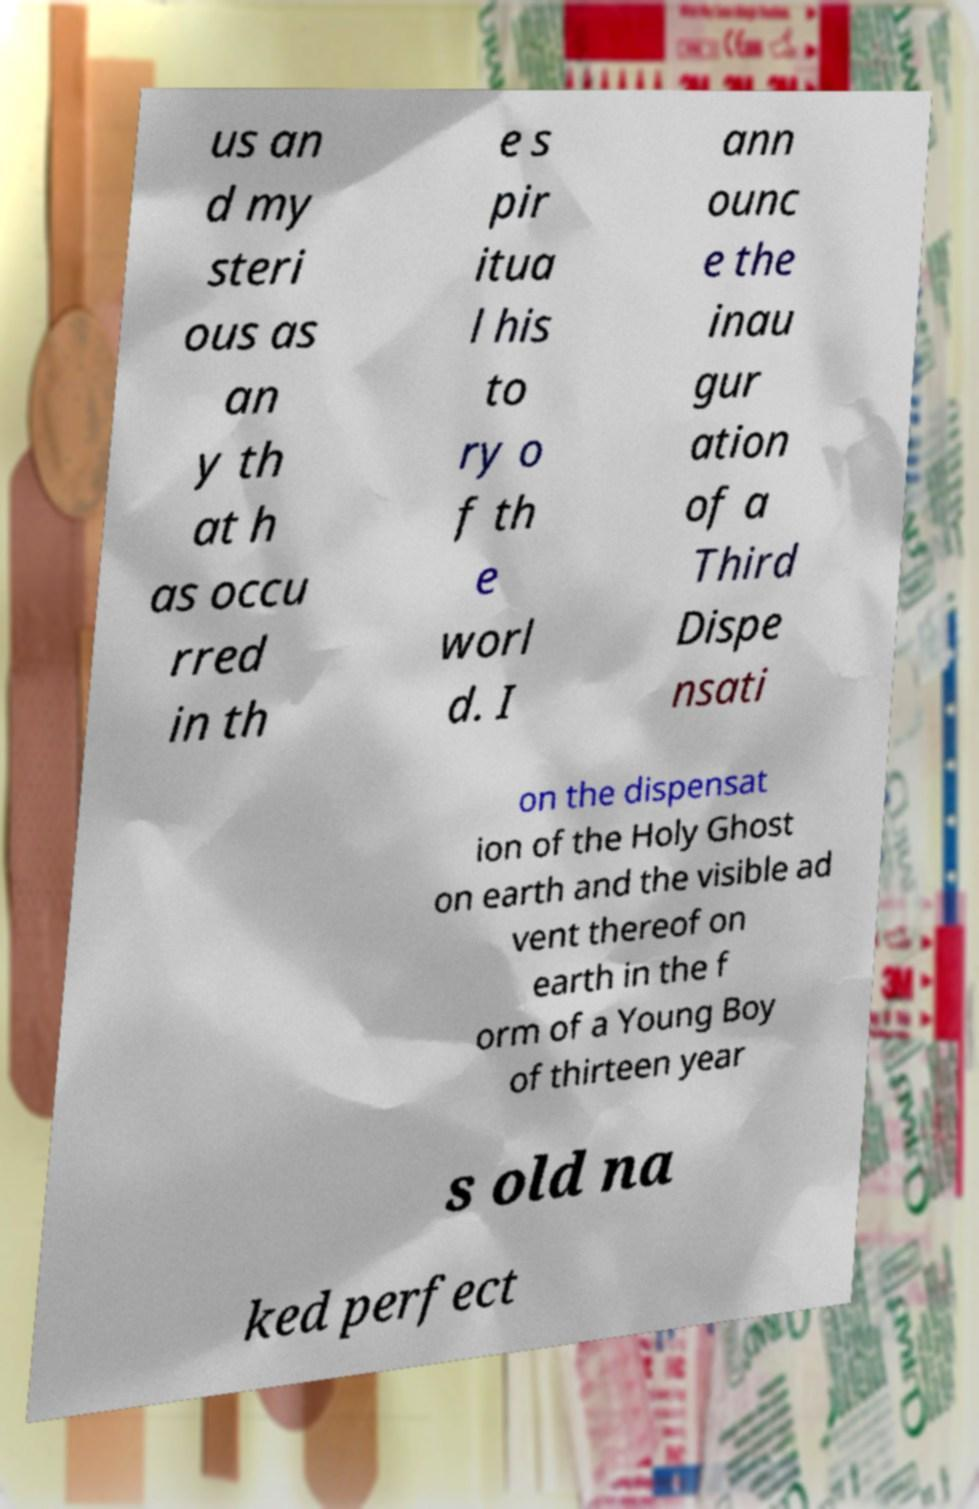What messages or text are displayed in this image? I need them in a readable, typed format. us an d my steri ous as an y th at h as occu rred in th e s pir itua l his to ry o f th e worl d. I ann ounc e the inau gur ation of a Third Dispe nsati on the dispensat ion of the Holy Ghost on earth and the visible ad vent thereof on earth in the f orm of a Young Boy of thirteen year s old na ked perfect 